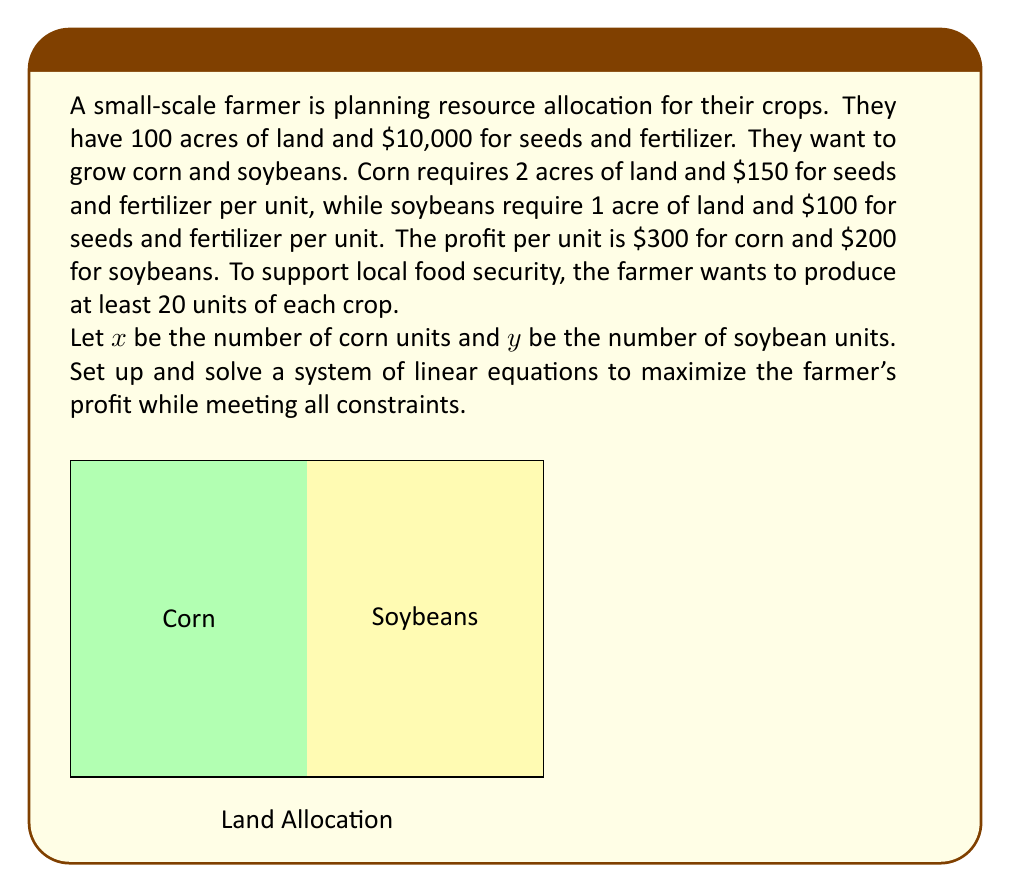Teach me how to tackle this problem. Let's approach this step-by-step:

1) First, let's set up the constraints:

   Land constraint: $2x + y \leq 100$
   Budget constraint: $150x + 100y \leq 10000$
   Minimum production: $x \geq 20$ and $y \geq 20$

2) The objective function to maximize profit is:

   $P = 300x + 200y$

3) To solve this linear programming problem, we'll use the corner point method. The feasible region is bounded by the constraints, so the optimal solution will be at one of the corner points.

4) Let's find the corner points by solving the equations:

   $2x + y = 100$ and $150x + 100y = 10000$

   Multiplying the first equation by 75:
   $150x + 75y = 7500$

   Subtracting this from the second equation:
   $25y = 2500$
   $y = 100$

   Substituting back:
   $2x + 100 = 100$
   $x = 0$

   However, this violates our minimum production constraint for corn.

5) Let's try the minimum production points:

   For $(20, 20)$:
   Land used: $2(20) + 20 = 60$ acres (feasible)
   Budget used: $150(20) + 100(20) = 5000$ (feasible)
   Profit: $300(20) + 200(20) = 10000$

   For $(20, 60)$:
   Land used: $2(20) + 60 = 100$ acres (feasible)
   Budget used: $150(20) + 100(60) = 9000$ (feasible)
   Profit: $300(20) + 200(60) = 18000$

   For $(40, 20)$:
   Land used: $2(40) + 20 = 100$ acres (feasible)
   Budget used: $150(40) + 100(20) = 8000$ (feasible)
   Profit: $300(40) + 200(20) = 16000$

6) The maximum profit is achieved at $(20, 60)$, producing 20 units of corn and 60 units of soybeans.
Answer: $(20, 60)$; 20 units of corn, 60 units of soybeans; $18000 profit 